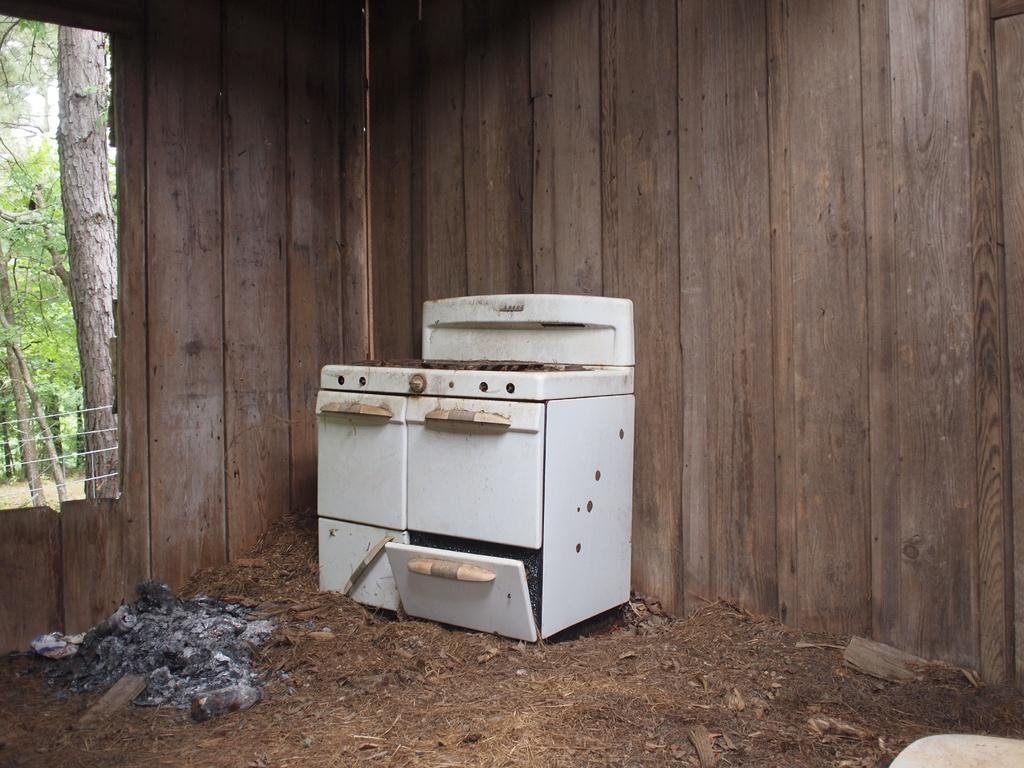What is the main object in the center of the image? There is an electric stove in the center of the image. What type of material is used for the wall in the background? There is a wooden wall in the background of the image. What can be seen in the distance beyond the wall? Trees are visible in the background of the image. Where is the sink located in the image? There is no sink present in the image. What type of shoe can be seen on the electric stove? There is no shoe present on the electric stove in the image. 